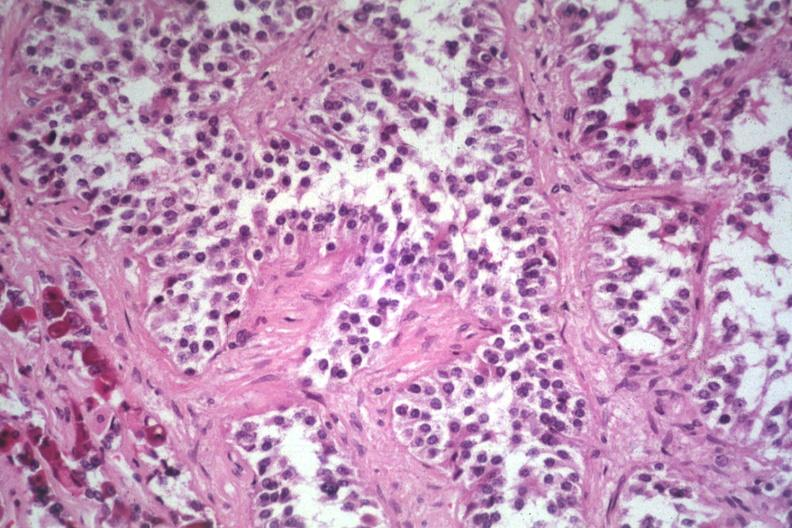s natural color present?
Answer the question using a single word or phrase. No 